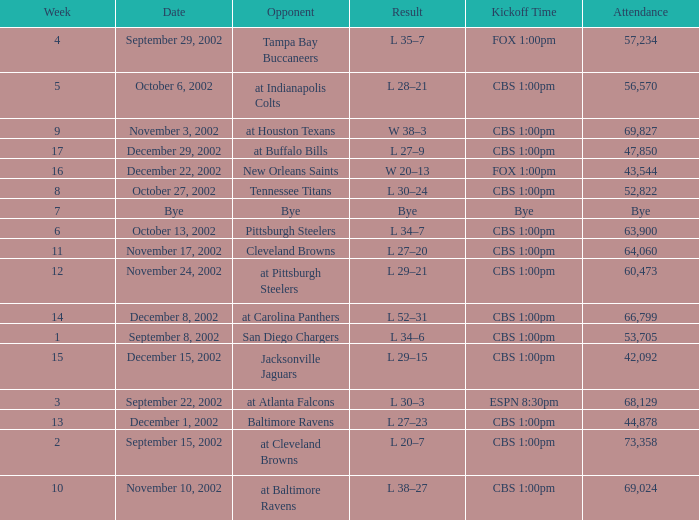What week number was the kickoff time cbs 1:00pm, with 60,473 people in attendance? 1.0. 